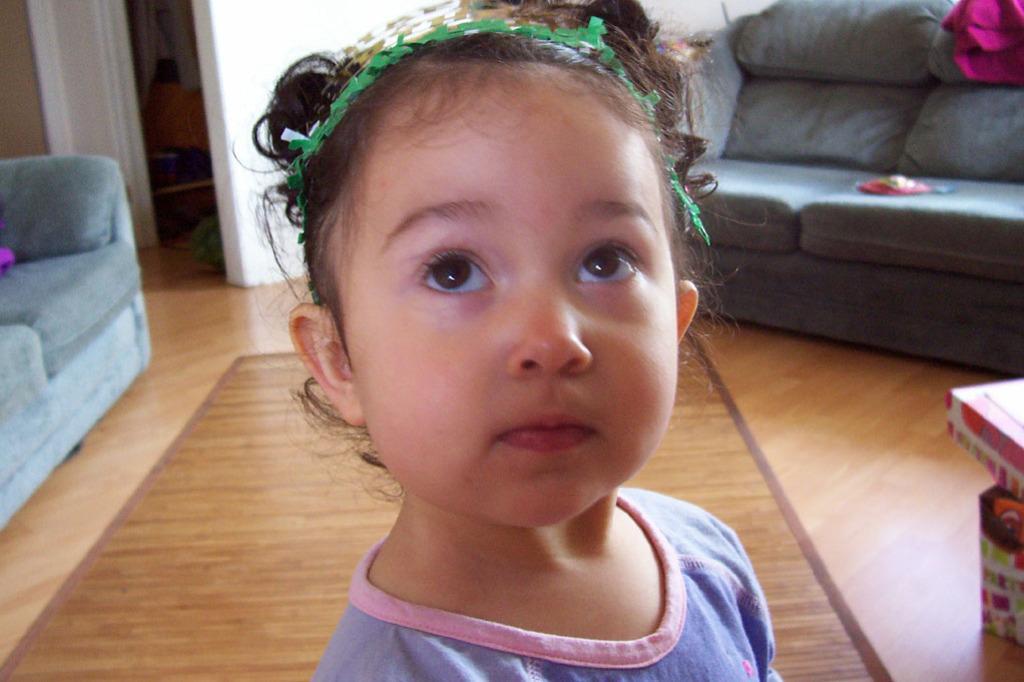Please provide a concise description of this image. Here a girl is standing on the floor behind her there are sofas and wall. 